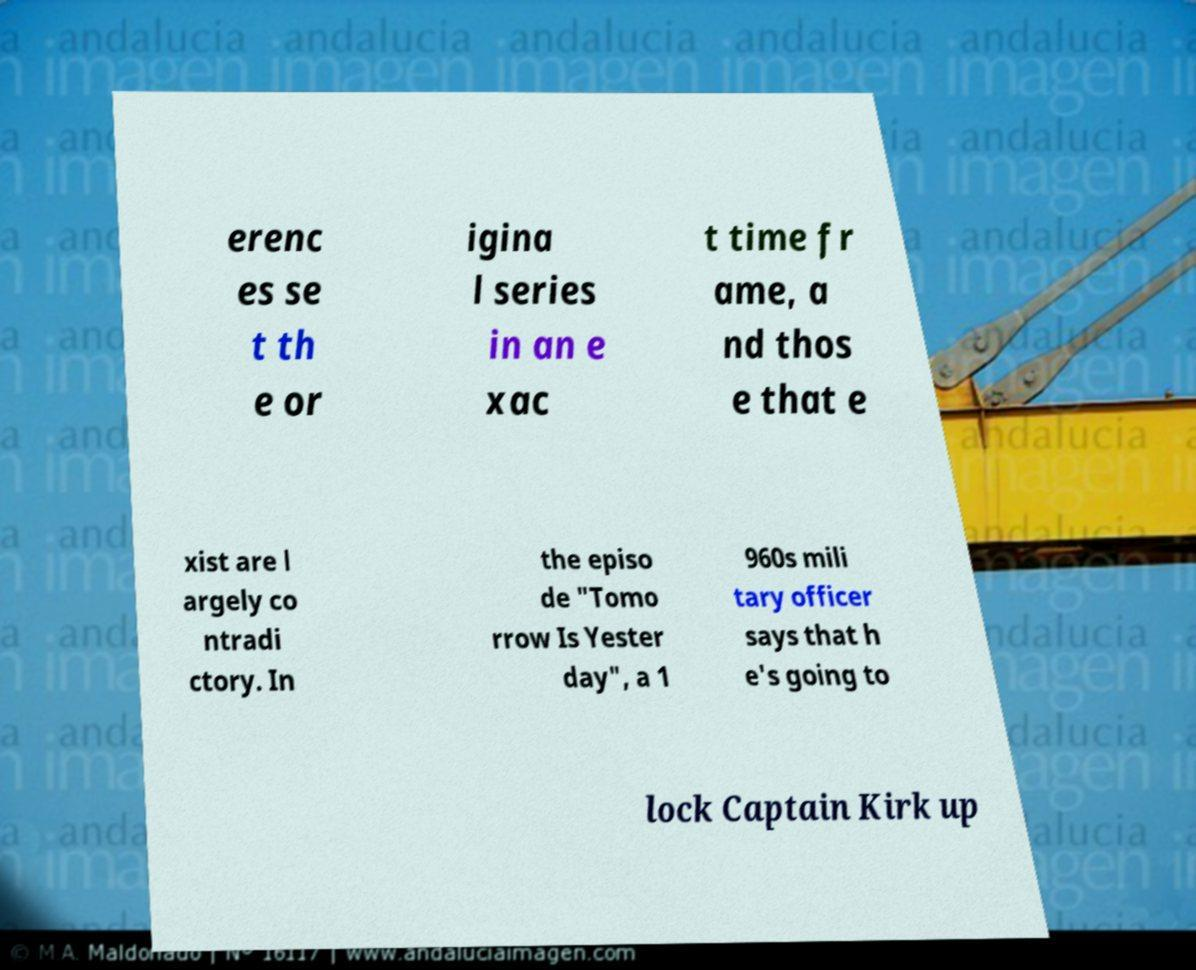Could you extract and type out the text from this image? erenc es se t th e or igina l series in an e xac t time fr ame, a nd thos e that e xist are l argely co ntradi ctory. In the episo de "Tomo rrow Is Yester day", a 1 960s mili tary officer says that h e's going to lock Captain Kirk up 